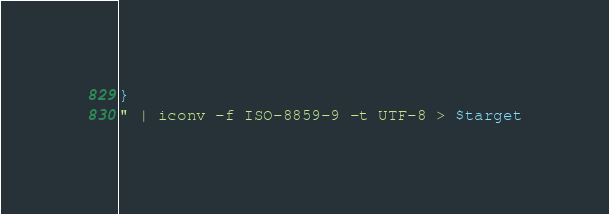<code> <loc_0><loc_0><loc_500><loc_500><_Bash_>}
" | iconv -f ISO-8859-9 -t UTF-8 > $target
</code> 